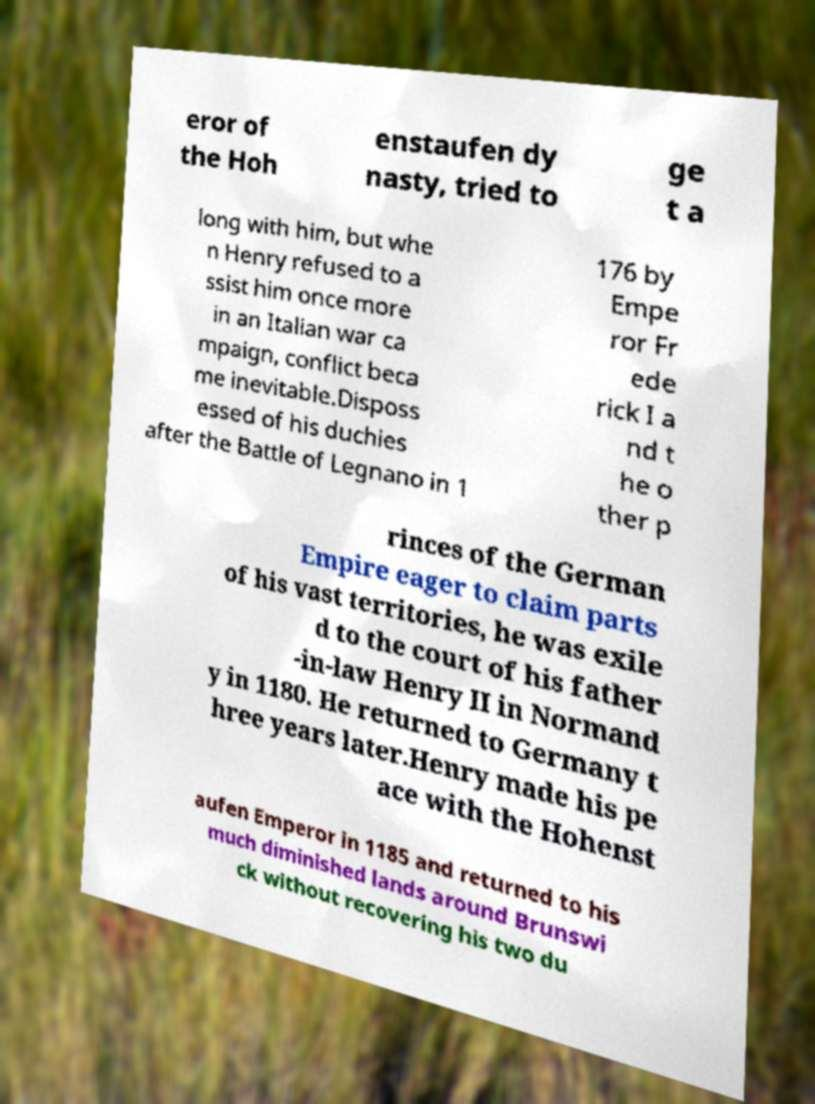Can you accurately transcribe the text from the provided image for me? eror of the Hoh enstaufen dy nasty, tried to ge t a long with him, but whe n Henry refused to a ssist him once more in an Italian war ca mpaign, conflict beca me inevitable.Disposs essed of his duchies after the Battle of Legnano in 1 176 by Empe ror Fr ede rick I a nd t he o ther p rinces of the German Empire eager to claim parts of his vast territories, he was exile d to the court of his father -in-law Henry II in Normand y in 1180. He returned to Germany t hree years later.Henry made his pe ace with the Hohenst aufen Emperor in 1185 and returned to his much diminished lands around Brunswi ck without recovering his two du 